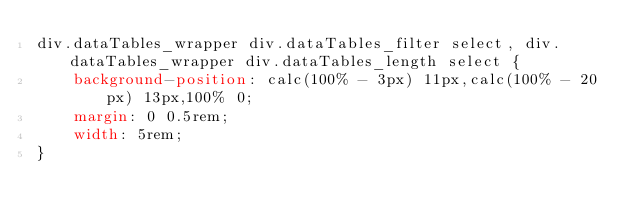Convert code to text. <code><loc_0><loc_0><loc_500><loc_500><_CSS_>div.dataTables_wrapper div.dataTables_filter select, div.dataTables_wrapper div.dataTables_length select {
    background-position: calc(100% - 3px) 11px,calc(100% - 20px) 13px,100% 0;
    margin: 0 0.5rem;
    width: 5rem;
}</code> 